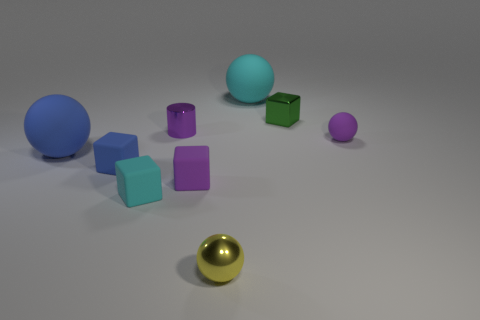What material is the small block that is the same color as the cylinder?
Keep it short and to the point. Rubber. Are the blue cube and the tiny green thing made of the same material?
Your response must be concise. No. There is a metallic sphere; are there any balls behind it?
Ensure brevity in your answer.  Yes. There is a small sphere that is behind the cyan object in front of the tiny green cube; what is its material?
Your answer should be very brief. Rubber. There is a purple matte thing that is the same shape as the tiny cyan matte object; what is its size?
Ensure brevity in your answer.  Small. Do the small matte ball and the cylinder have the same color?
Keep it short and to the point. Yes. There is a sphere that is right of the small metallic cylinder and in front of the tiny purple matte ball; what color is it?
Offer a terse response. Yellow. Is the size of the cyan rubber object that is left of the purple shiny thing the same as the tiny metal ball?
Make the answer very short. Yes. Is there anything else that has the same shape as the big cyan rubber object?
Offer a very short reply. Yes. Do the purple cylinder and the tiny purple object that is on the right side of the large cyan sphere have the same material?
Keep it short and to the point. No. 